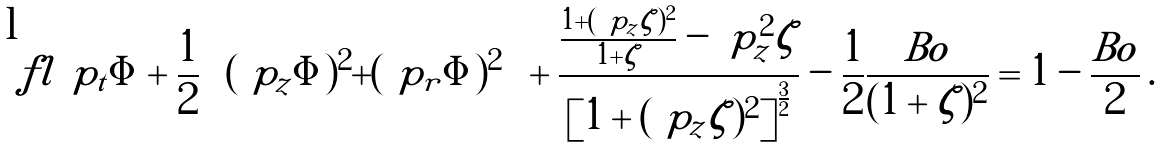Convert formula to latex. <formula><loc_0><loc_0><loc_500><loc_500>\ f l \ p _ { t } \Phi + \frac { 1 } { 2 } \left [ ( \ p _ { z } \Phi ) ^ { 2 } + ( \ p _ { r } \Phi ) ^ { 2 } \right ] + \frac { \frac { 1 + ( \ p _ { z } \zeta ) ^ { 2 } } { 1 + \zeta } - \ p _ { z } ^ { 2 } \zeta } { \left [ 1 + ( \ p _ { z } \zeta ) ^ { 2 } \right ] ^ { \frac { 3 } { 2 } } } - \frac { 1 } { 2 } \frac { B o } { ( 1 + \zeta ) ^ { 2 } } = 1 - \frac { B o } { 2 } \, .</formula> 